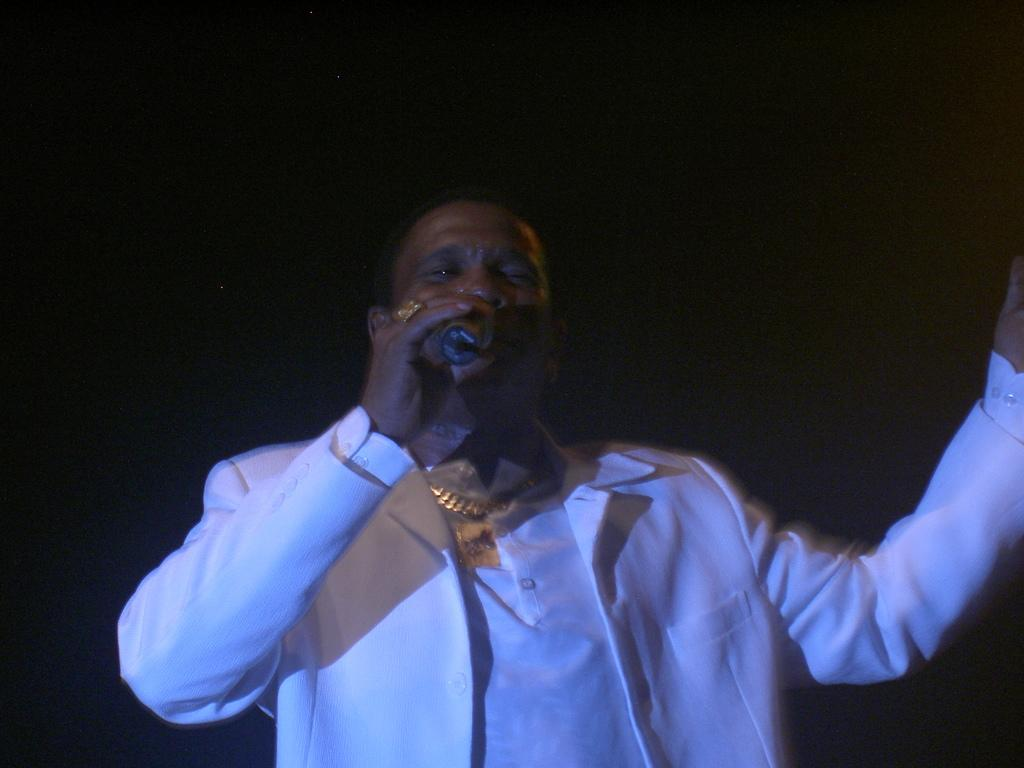Who is the main subject in the image? There is a man in the image. What is the man wearing? The man is wearing a white dress. What is the man doing in the image? The man is standing and holding a microphone in his hand. What can be seen in the background of the image? The background of the image is dark. What type of sea creature is visible in the image? There is no sea creature present in the image; it features a man wearing a white dress and holding a microphone. What kind of drug is the man using in the image? There is no drug use depicted in the image; the man is simply holding a microphone. 